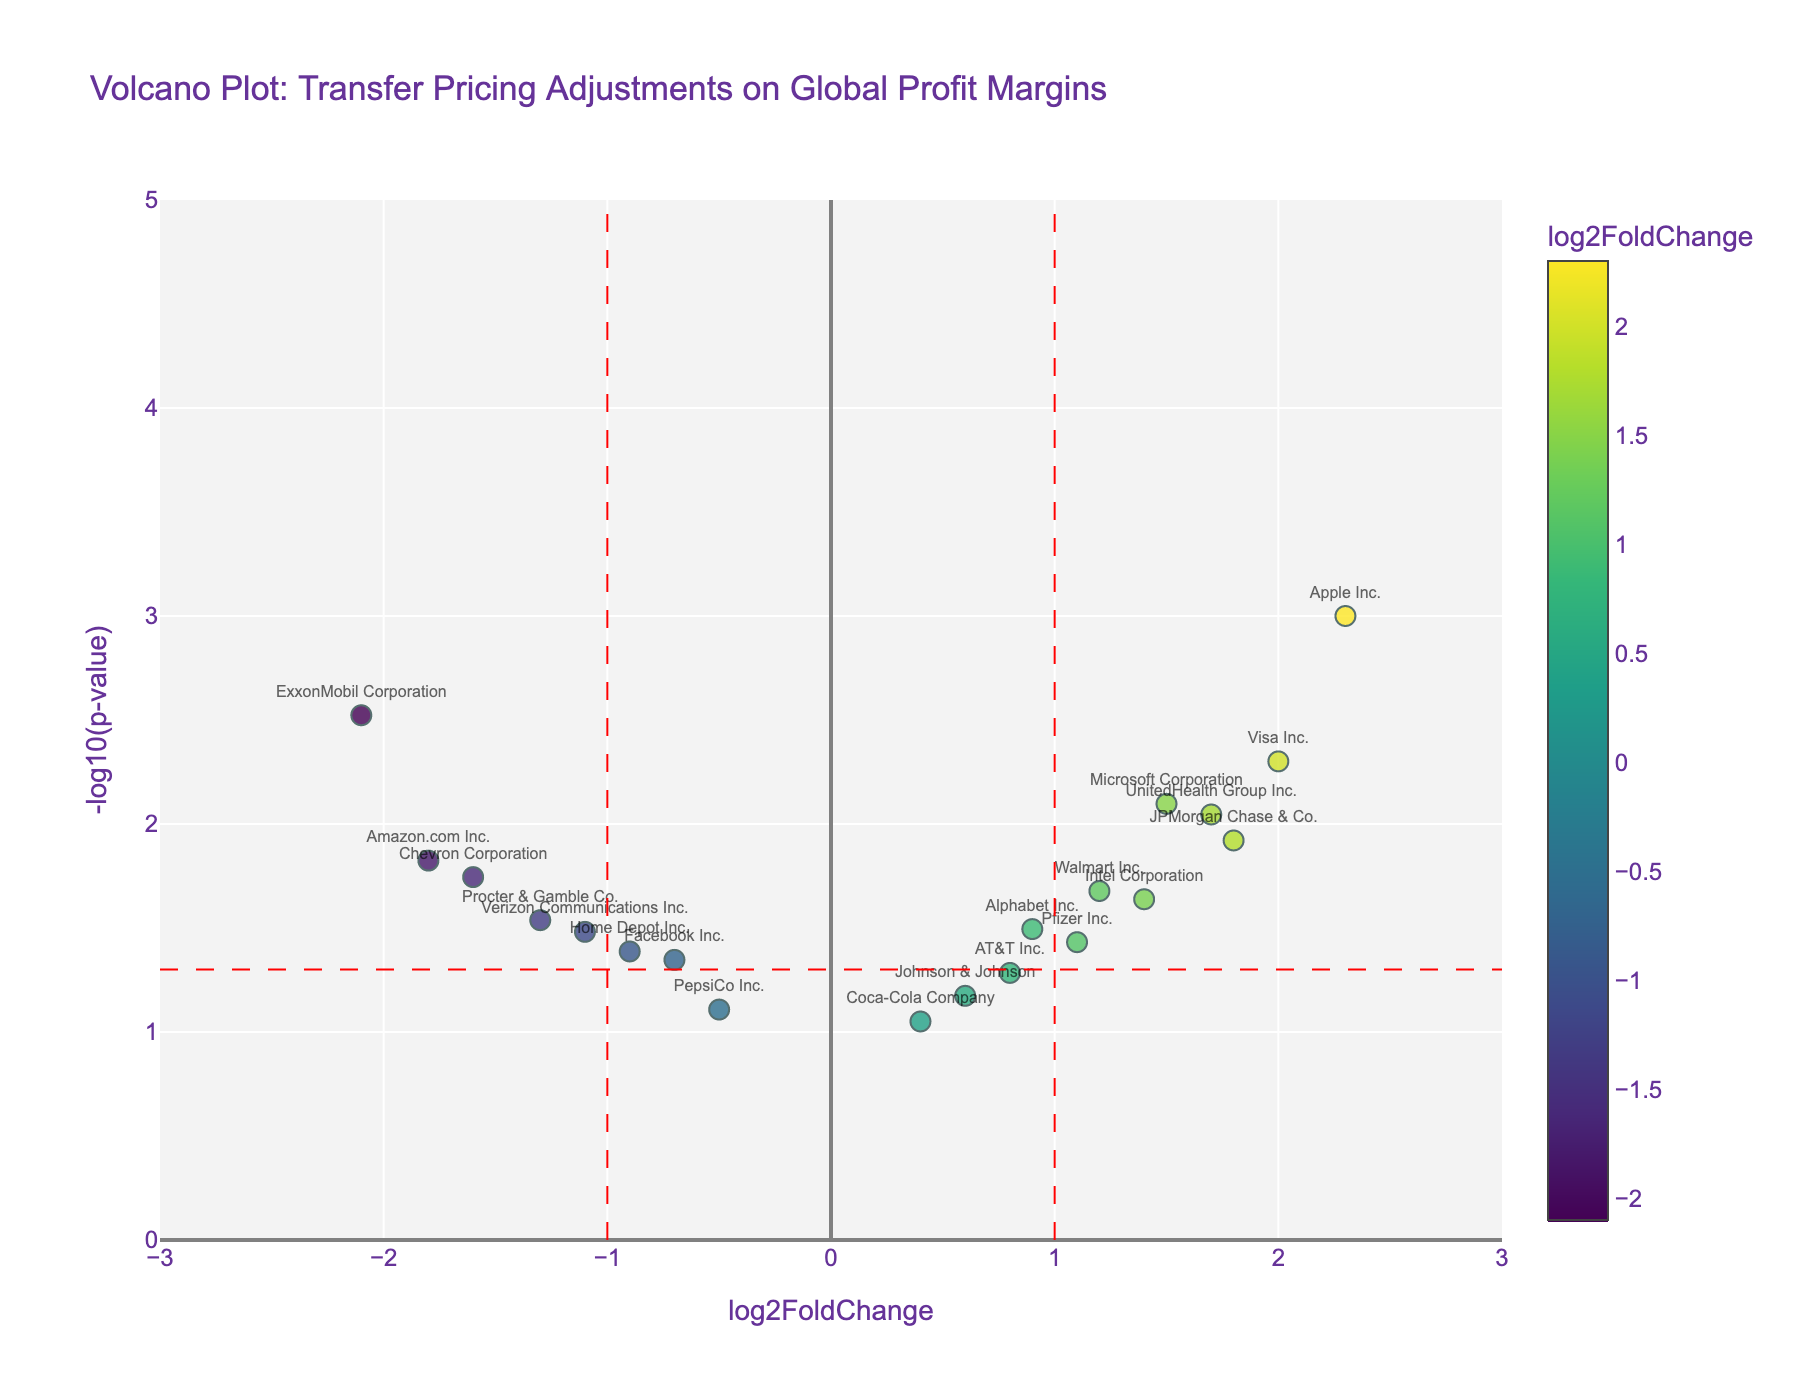How many companies have a significant p-value below 0.05? Significant p-values are indicated by points above the horizontal threshold line (y = -log10(0.05) ≈ 1.301). Count the number of points above this line.
Answer: 15 What is the log2FoldChange of ExxonMobil Corporation? Locate the point labeled "ExxonMobil Corporation" and note its position on the x-axis.
Answer: -2.1 Which company has the highest log2FoldChange and what is its corresponding p-value? Identify the point furthest to the right. This point is labeled "Apple Inc." with coordinates (2.3, -log10(p-value)).
Answer: Apple Inc., 0.001 Are there more companies with positive or negative log2FoldChange values? Compare the number of points to the right of the origin (0, 0) with those to the left. There are 11 points with positive log2FoldChange and 9 with negative.
Answer: Positive What does a point farthest to the left of the graph indicate about its log2FoldChange and p-value? This point represents the most negatively impacted company on the log2FoldChange axis, with a very low p-value. This point is ExxonMobil Corporation with log2FoldChange of -2.1 and p-value of 0.003.
Answer: log2FoldChange: -2.1, p-value: 0.003 Which company has a similar p-value but opposite sign log2FoldChange compared to Microsoft Corporation? Microsoft Corporation has a log2FoldChange of 1.5 and p-value of 0.008. Locate a point with a similar distance from the origin on the negative side. This point is Chevron Corporation with log2FoldChange of -1.6 and p-value of 0.018.
Answer: Chevron Corporation How many companies show a log2FoldChange greater than 1 and have a significant p-value below 0.05? Find points to the right of the vertical threshold (x = 1) and above the horizontal threshold line (y ≈ 1.301). The companies are Apple Inc., Microsoft Corporation, Visa Inc., JPMorgan Chase & Co., UnitedHealth Group Inc., and Intel Corporation.
Answer: 6 Which company is closest to the threshold line of p-value equal to 0.05 but still signifies statistical insignificance? Look for the point nearest to the horizontal threshold (y ≈ -log10(0.05)), and slightly below it. AT&T Inc. appears closest with a log2FoldChange of 0.8 and p-value of 0.052.
Answer: AT&T Inc Is there any company with a positive log2FoldChange and non-significant p-value? Check for companies to the right of the origin but below the horizontal threshold line. Coca-Cola Company shows log2FoldChange of 0.4 and p-value of 0.089.
Answer: Coca-Cola Company 